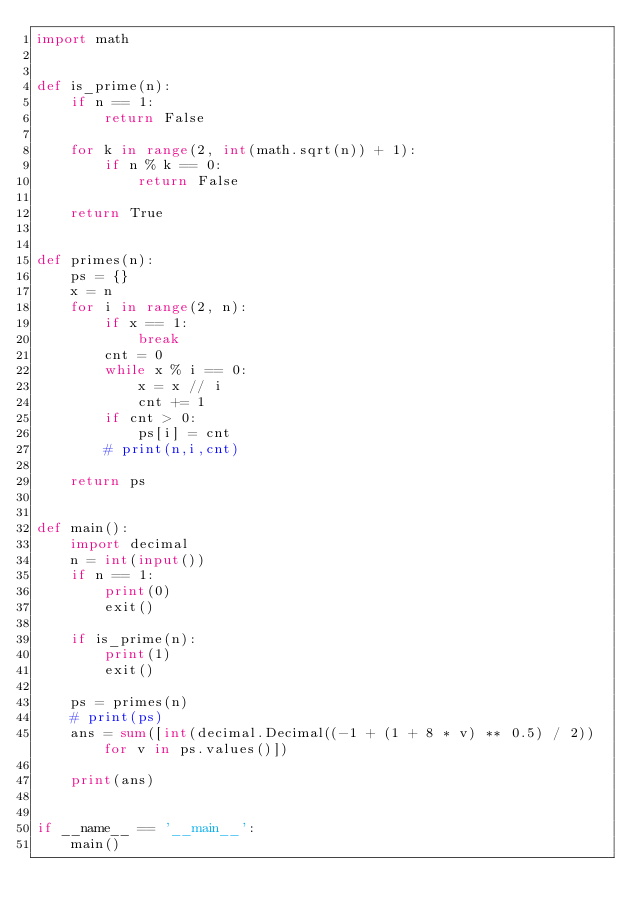Convert code to text. <code><loc_0><loc_0><loc_500><loc_500><_Python_>import math


def is_prime(n):
    if n == 1:
        return False

    for k in range(2, int(math.sqrt(n)) + 1):
        if n % k == 0:
            return False

    return True


def primes(n):
    ps = {}
    x = n
    for i in range(2, n):
        if x == 1:
            break
        cnt = 0
        while x % i == 0:
            x = x // i
            cnt += 1
        if cnt > 0:
            ps[i] = cnt
        # print(n,i,cnt)

    return ps


def main():
    import decimal
    n = int(input())
    if n == 1:
        print(0)
        exit()

    if is_prime(n):
        print(1)
        exit()

    ps = primes(n)
    # print(ps)
    ans = sum([int(decimal.Decimal((-1 + (1 + 8 * v) ** 0.5) / 2)) for v in ps.values()])

    print(ans)


if __name__ == '__main__':
    main()
</code> 